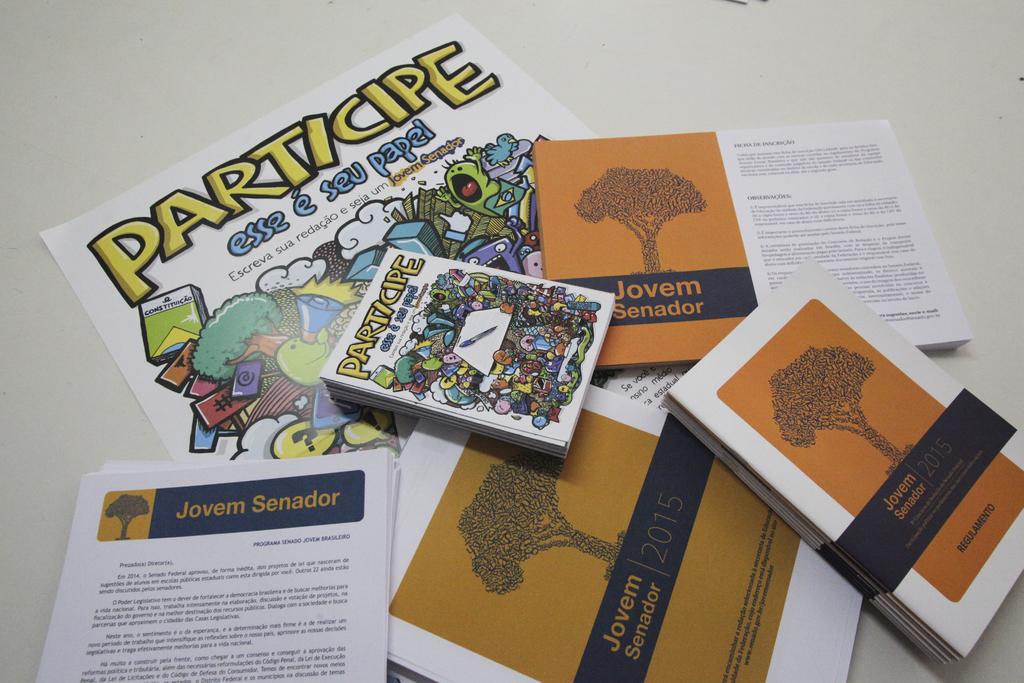What year was the book with the tree written?
Give a very brief answer. 2015. What is the name of the book with a tree on it?
Ensure brevity in your answer.  Jovem senador. 